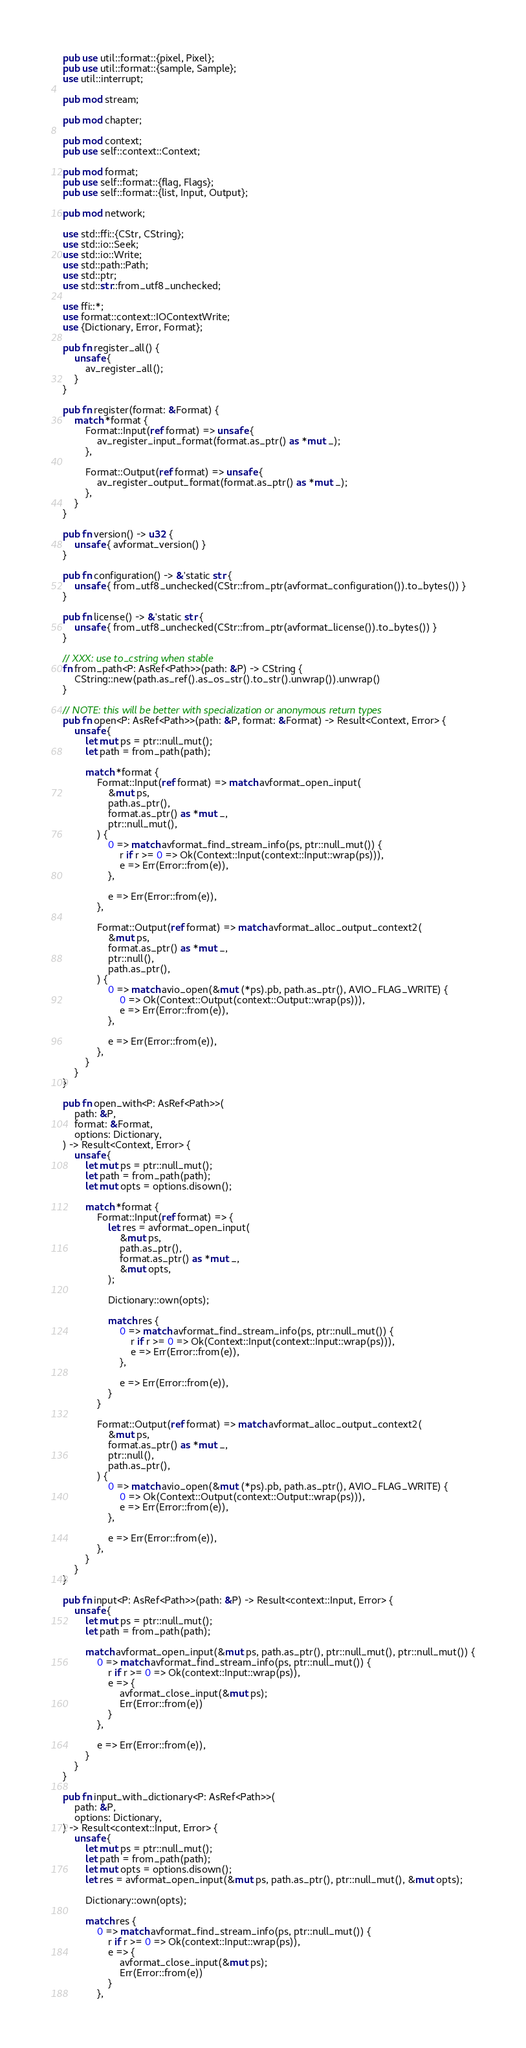Convert code to text. <code><loc_0><loc_0><loc_500><loc_500><_Rust_>pub use util::format::{pixel, Pixel};
pub use util::format::{sample, Sample};
use util::interrupt;

pub mod stream;

pub mod chapter;

pub mod context;
pub use self::context::Context;

pub mod format;
pub use self::format::{flag, Flags};
pub use self::format::{list, Input, Output};

pub mod network;

use std::ffi::{CStr, CString};
use std::io::Seek;
use std::io::Write;
use std::path::Path;
use std::ptr;
use std::str::from_utf8_unchecked;

use ffi::*;
use format::context::IOContextWrite;
use {Dictionary, Error, Format};

pub fn register_all() {
    unsafe {
        av_register_all();
    }
}

pub fn register(format: &Format) {
    match *format {
        Format::Input(ref format) => unsafe {
            av_register_input_format(format.as_ptr() as *mut _);
        },

        Format::Output(ref format) => unsafe {
            av_register_output_format(format.as_ptr() as *mut _);
        },
    }
}

pub fn version() -> u32 {
    unsafe { avformat_version() }
}

pub fn configuration() -> &'static str {
    unsafe { from_utf8_unchecked(CStr::from_ptr(avformat_configuration()).to_bytes()) }
}

pub fn license() -> &'static str {
    unsafe { from_utf8_unchecked(CStr::from_ptr(avformat_license()).to_bytes()) }
}

// XXX: use to_cstring when stable
fn from_path<P: AsRef<Path>>(path: &P) -> CString {
    CString::new(path.as_ref().as_os_str().to_str().unwrap()).unwrap()
}

// NOTE: this will be better with specialization or anonymous return types
pub fn open<P: AsRef<Path>>(path: &P, format: &Format) -> Result<Context, Error> {
    unsafe {
        let mut ps = ptr::null_mut();
        let path = from_path(path);

        match *format {
            Format::Input(ref format) => match avformat_open_input(
                &mut ps,
                path.as_ptr(),
                format.as_ptr() as *mut _,
                ptr::null_mut(),
            ) {
                0 => match avformat_find_stream_info(ps, ptr::null_mut()) {
                    r if r >= 0 => Ok(Context::Input(context::Input::wrap(ps))),
                    e => Err(Error::from(e)),
                },

                e => Err(Error::from(e)),
            },

            Format::Output(ref format) => match avformat_alloc_output_context2(
                &mut ps,
                format.as_ptr() as *mut _,
                ptr::null(),
                path.as_ptr(),
            ) {
                0 => match avio_open(&mut (*ps).pb, path.as_ptr(), AVIO_FLAG_WRITE) {
                    0 => Ok(Context::Output(context::Output::wrap(ps))),
                    e => Err(Error::from(e)),
                },

                e => Err(Error::from(e)),
            },
        }
    }
}

pub fn open_with<P: AsRef<Path>>(
    path: &P,
    format: &Format,
    options: Dictionary,
) -> Result<Context, Error> {
    unsafe {
        let mut ps = ptr::null_mut();
        let path = from_path(path);
        let mut opts = options.disown();

        match *format {
            Format::Input(ref format) => {
                let res = avformat_open_input(
                    &mut ps,
                    path.as_ptr(),
                    format.as_ptr() as *mut _,
                    &mut opts,
                );

                Dictionary::own(opts);

                match res {
                    0 => match avformat_find_stream_info(ps, ptr::null_mut()) {
                        r if r >= 0 => Ok(Context::Input(context::Input::wrap(ps))),
                        e => Err(Error::from(e)),
                    },

                    e => Err(Error::from(e)),
                }
            }

            Format::Output(ref format) => match avformat_alloc_output_context2(
                &mut ps,
                format.as_ptr() as *mut _,
                ptr::null(),
                path.as_ptr(),
            ) {
                0 => match avio_open(&mut (*ps).pb, path.as_ptr(), AVIO_FLAG_WRITE) {
                    0 => Ok(Context::Output(context::Output::wrap(ps))),
                    e => Err(Error::from(e)),
                },

                e => Err(Error::from(e)),
            },
        }
    }
}

pub fn input<P: AsRef<Path>>(path: &P) -> Result<context::Input, Error> {
    unsafe {
        let mut ps = ptr::null_mut();
        let path = from_path(path);

        match avformat_open_input(&mut ps, path.as_ptr(), ptr::null_mut(), ptr::null_mut()) {
            0 => match avformat_find_stream_info(ps, ptr::null_mut()) {
                r if r >= 0 => Ok(context::Input::wrap(ps)),
                e => {
                    avformat_close_input(&mut ps);
                    Err(Error::from(e))
                }
            },

            e => Err(Error::from(e)),
        }
    }
}

pub fn input_with_dictionary<P: AsRef<Path>>(
    path: &P,
    options: Dictionary,
) -> Result<context::Input, Error> {
    unsafe {
        let mut ps = ptr::null_mut();
        let path = from_path(path);
        let mut opts = options.disown();
        let res = avformat_open_input(&mut ps, path.as_ptr(), ptr::null_mut(), &mut opts);

        Dictionary::own(opts);

        match res {
            0 => match avformat_find_stream_info(ps, ptr::null_mut()) {
                r if r >= 0 => Ok(context::Input::wrap(ps)),
                e => {
                    avformat_close_input(&mut ps);
                    Err(Error::from(e))
                }
            },
</code> 